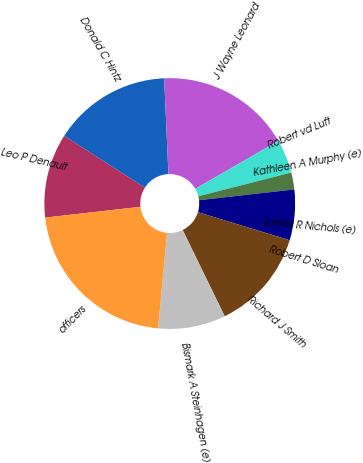Convert chart to OTSL. <chart><loc_0><loc_0><loc_500><loc_500><pie_chart><fcel>Leo P Denault<fcel>Donald C Hintz<fcel>J Wayne Leonard<fcel>Robert vd Luft<fcel>Kathleen A Murphy (e)<fcel>James R Nichols (e)<fcel>Robert D Sloan<fcel>Richard J Smith<fcel>Bismark A Steinhagen (e)<fcel>officers<nl><fcel>10.87%<fcel>15.21%<fcel>17.38%<fcel>4.35%<fcel>2.18%<fcel>6.52%<fcel>0.01%<fcel>13.04%<fcel>8.7%<fcel>21.73%<nl></chart> 